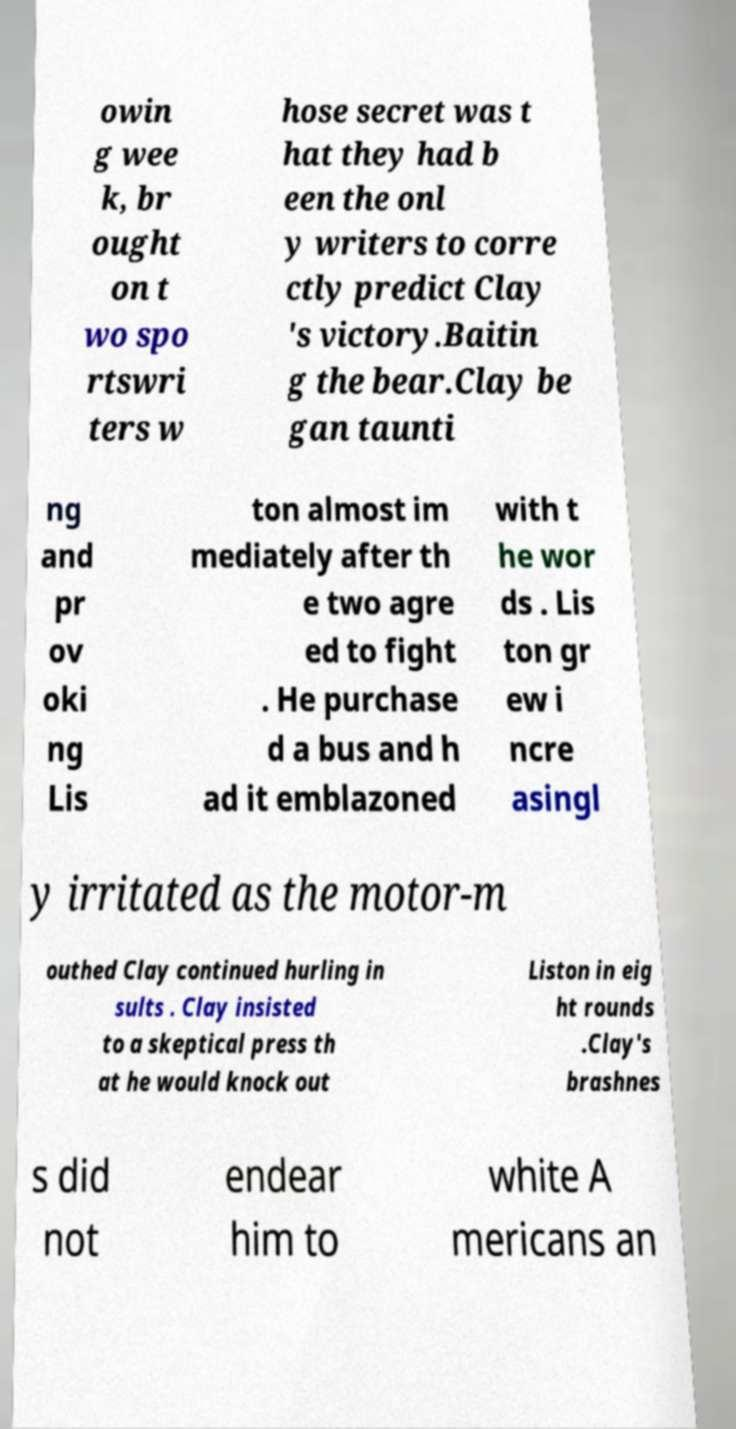Can you accurately transcribe the text from the provided image for me? owin g wee k, br ought on t wo spo rtswri ters w hose secret was t hat they had b een the onl y writers to corre ctly predict Clay 's victory.Baitin g the bear.Clay be gan taunti ng and pr ov oki ng Lis ton almost im mediately after th e two agre ed to fight . He purchase d a bus and h ad it emblazoned with t he wor ds . Lis ton gr ew i ncre asingl y irritated as the motor-m outhed Clay continued hurling in sults . Clay insisted to a skeptical press th at he would knock out Liston in eig ht rounds .Clay's brashnes s did not endear him to white A mericans an 